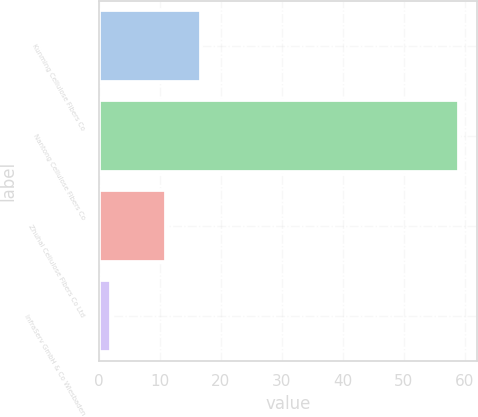<chart> <loc_0><loc_0><loc_500><loc_500><bar_chart><fcel>Kunming Cellulose Fibers Co<fcel>Nantong Cellulose Fibers Co<fcel>Zhuhai Cellulose Fibers Co Ltd<fcel>InfraServ GmbH & Co Wiesbaden<nl><fcel>16.7<fcel>59<fcel>11<fcel>2<nl></chart> 